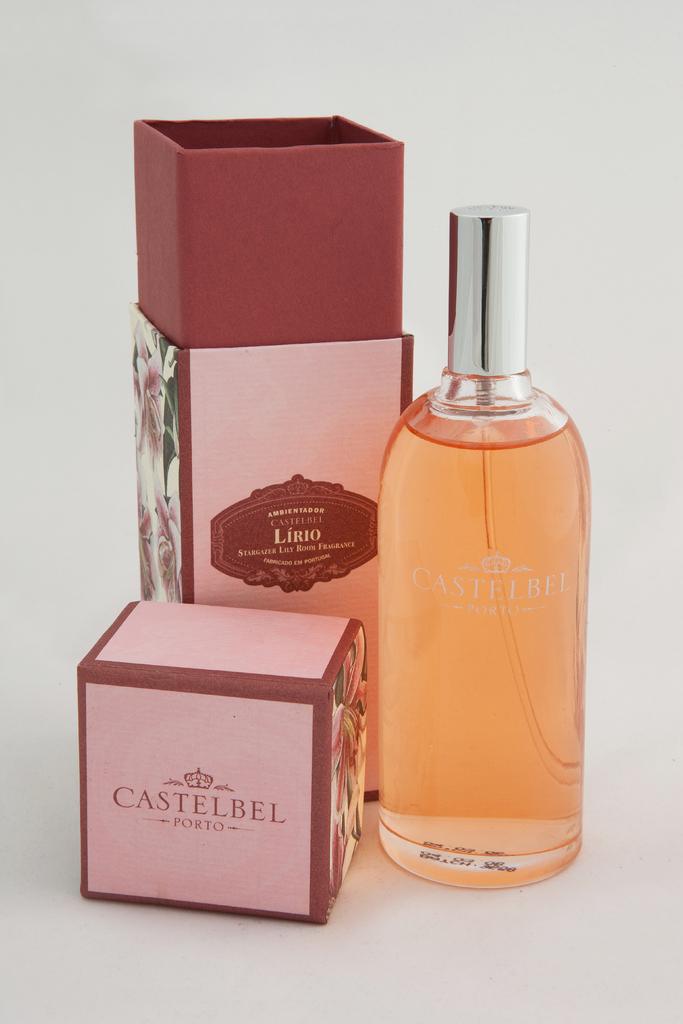What is the brand of this toiletry ?
Offer a very short reply. Castelbel. What version of castelbel perfume is this?
Offer a very short reply. Lirio. 